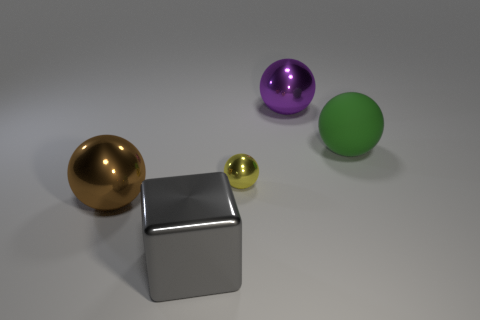What is the color of the big matte object that is the same shape as the tiny yellow object?
Keep it short and to the point. Green. What is the material of the sphere that is both to the right of the large brown object and in front of the big green rubber ball?
Ensure brevity in your answer.  Metal. Is the material of the thing left of the gray thing the same as the object on the right side of the purple sphere?
Offer a very short reply. No. How big is the purple metal thing?
Your response must be concise. Large. There is a purple thing that is the same shape as the green rubber object; what size is it?
Give a very brief answer. Large. There is a big green rubber object; what number of purple shiny objects are behind it?
Give a very brief answer. 1. What is the color of the big object in front of the sphere to the left of the gray object?
Ensure brevity in your answer.  Gray. Are there any other things that have the same shape as the large purple metallic object?
Your answer should be compact. Yes. Are there the same number of tiny shiny objects that are on the right side of the yellow thing and metallic things that are in front of the green matte thing?
Make the answer very short. No. How many balls are either large gray things or big metallic objects?
Your answer should be compact. 2. 